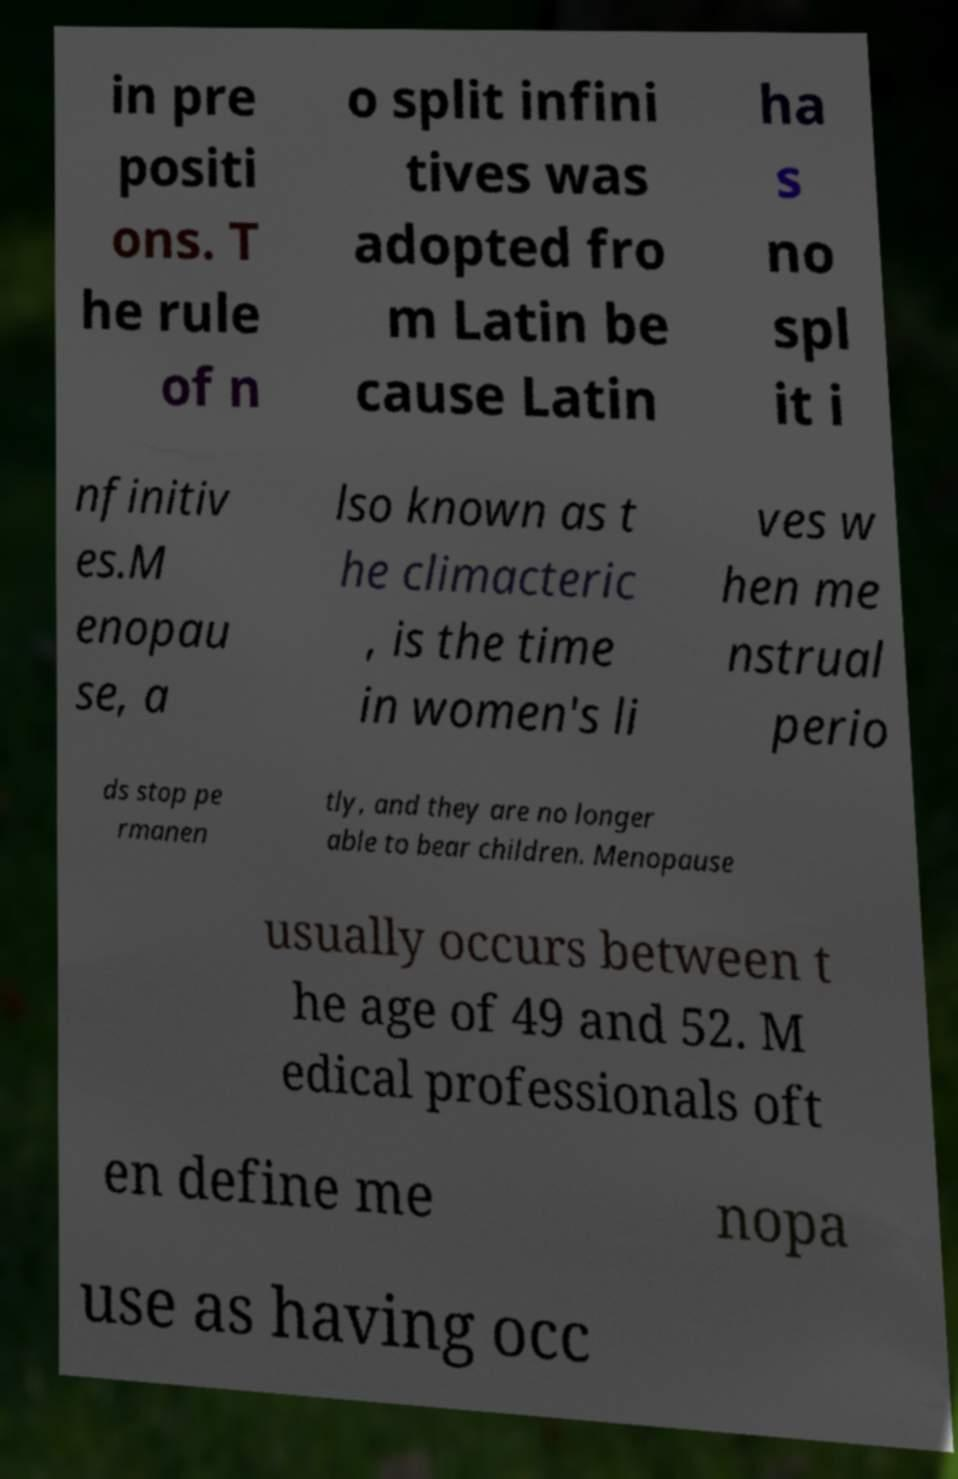I need the written content from this picture converted into text. Can you do that? in pre positi ons. T he rule of n o split infini tives was adopted fro m Latin be cause Latin ha s no spl it i nfinitiv es.M enopau se, a lso known as t he climacteric , is the time in women's li ves w hen me nstrual perio ds stop pe rmanen tly, and they are no longer able to bear children. Menopause usually occurs between t he age of 49 and 52. M edical professionals oft en define me nopa use as having occ 